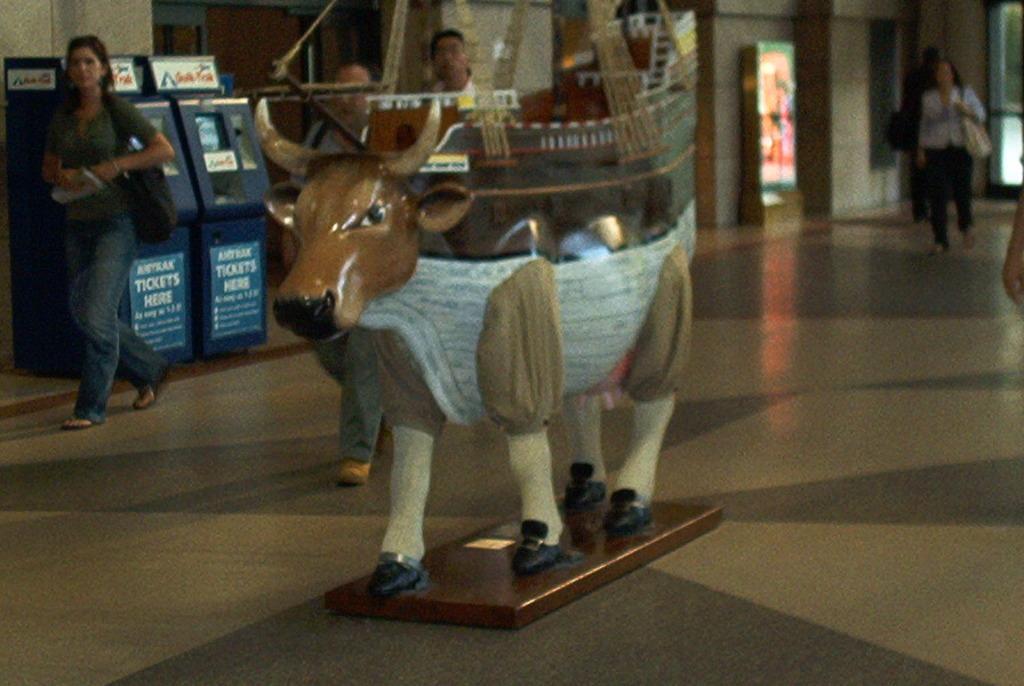How would you summarize this image in a sentence or two? There is a statue on the floor, on which, there are persons walking. On the left side, there are machines, near wall and there is a hoarding. In the background, there are other objects. 